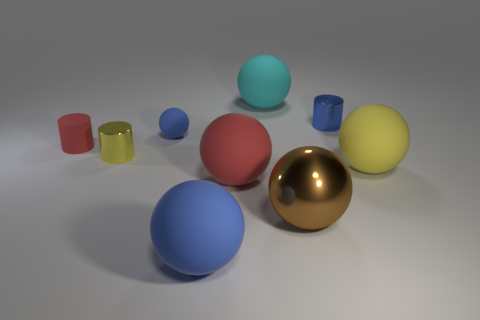Does the arrangement of the objects suggest any particular theme? The arrangement of the spheres and cylinders in varying sizes and colors could suggest themes of diversity and harmony, as they coexist peacefully in the shared space. Additionally, the layout might imply principles of balance and proportion in visual design, with the objects strategically placed to create a pleasant and cohesive composition. 